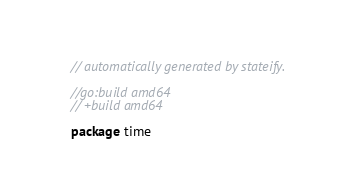<code> <loc_0><loc_0><loc_500><loc_500><_Go_>// automatically generated by stateify.

//go:build amd64
// +build amd64

package time
</code> 